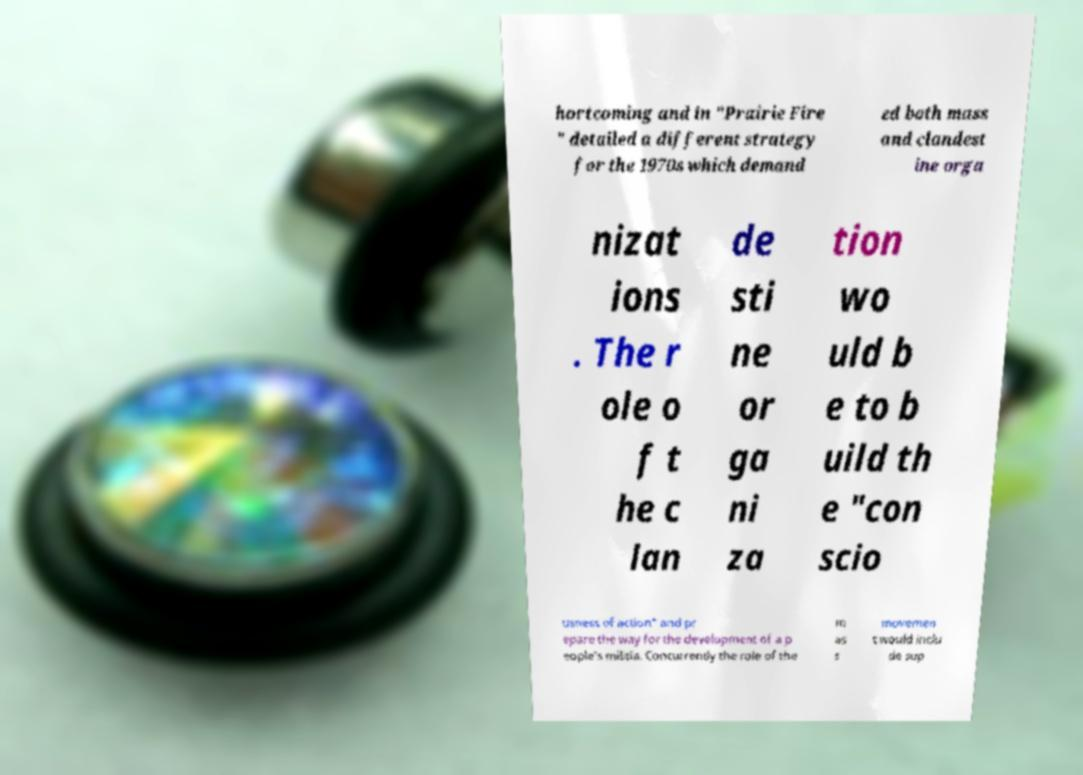Can you read and provide the text displayed in the image?This photo seems to have some interesting text. Can you extract and type it out for me? hortcoming and in "Prairie Fire " detailed a different strategy for the 1970s which demand ed both mass and clandest ine orga nizat ions . The r ole o f t he c lan de sti ne or ga ni za tion wo uld b e to b uild th e "con scio usness of action" and pr epare the way for the development of a p eople's militia. Concurrently the role of the m as s movemen t would inclu de sup 